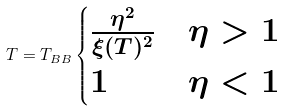<formula> <loc_0><loc_0><loc_500><loc_500>T = T _ { B B } \begin{cases} \frac { \eta ^ { 2 } } { \xi ( T ) ^ { 2 } } & \eta > 1 \\ 1 & \eta < 1 \end{cases}</formula> 